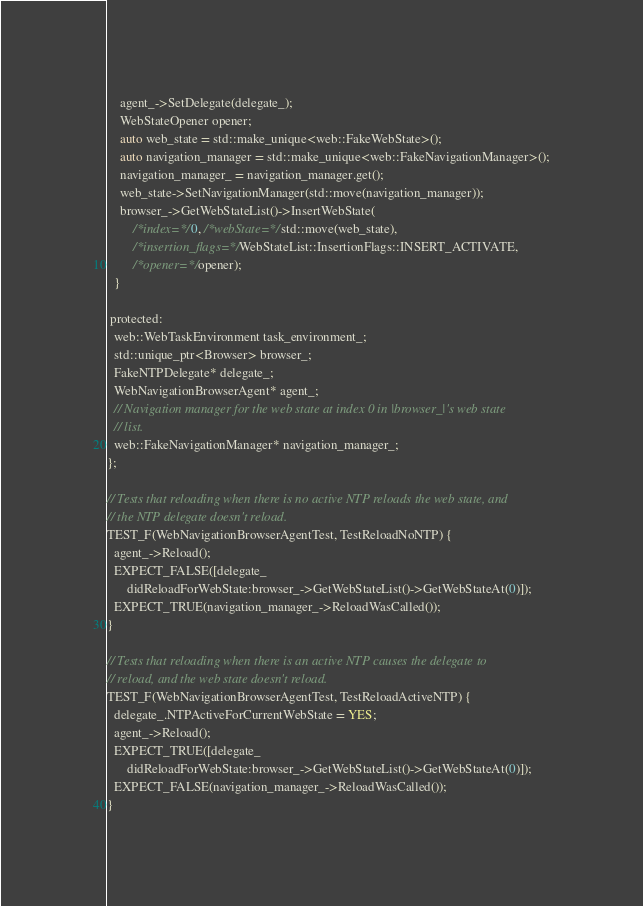<code> <loc_0><loc_0><loc_500><loc_500><_ObjectiveC_>    agent_->SetDelegate(delegate_);
    WebStateOpener opener;
    auto web_state = std::make_unique<web::FakeWebState>();
    auto navigation_manager = std::make_unique<web::FakeNavigationManager>();
    navigation_manager_ = navigation_manager.get();
    web_state->SetNavigationManager(std::move(navigation_manager));
    browser_->GetWebStateList()->InsertWebState(
        /*index=*/0, /*webState=*/std::move(web_state),
        /*insertion_flags=*/WebStateList::InsertionFlags::INSERT_ACTIVATE,
        /*opener=*/opener);
  }

 protected:
  web::WebTaskEnvironment task_environment_;
  std::unique_ptr<Browser> browser_;
  FakeNTPDelegate* delegate_;
  WebNavigationBrowserAgent* agent_;
  // Navigation manager for the web state at index 0 in |browser_|'s web state
  // list.
  web::FakeNavigationManager* navigation_manager_;
};

// Tests that reloading when there is no active NTP reloads the web state, and
// the NTP delegate doesn't reload.
TEST_F(WebNavigationBrowserAgentTest, TestReloadNoNTP) {
  agent_->Reload();
  EXPECT_FALSE([delegate_
      didReloadForWebState:browser_->GetWebStateList()->GetWebStateAt(0)]);
  EXPECT_TRUE(navigation_manager_->ReloadWasCalled());
}

// Tests that reloading when there is an active NTP causes the delegate to
// reload, and the web state doesn't reload.
TEST_F(WebNavigationBrowserAgentTest, TestReloadActiveNTP) {
  delegate_.NTPActiveForCurrentWebState = YES;
  agent_->Reload();
  EXPECT_TRUE([delegate_
      didReloadForWebState:browser_->GetWebStateList()->GetWebStateAt(0)]);
  EXPECT_FALSE(navigation_manager_->ReloadWasCalled());
}
</code> 